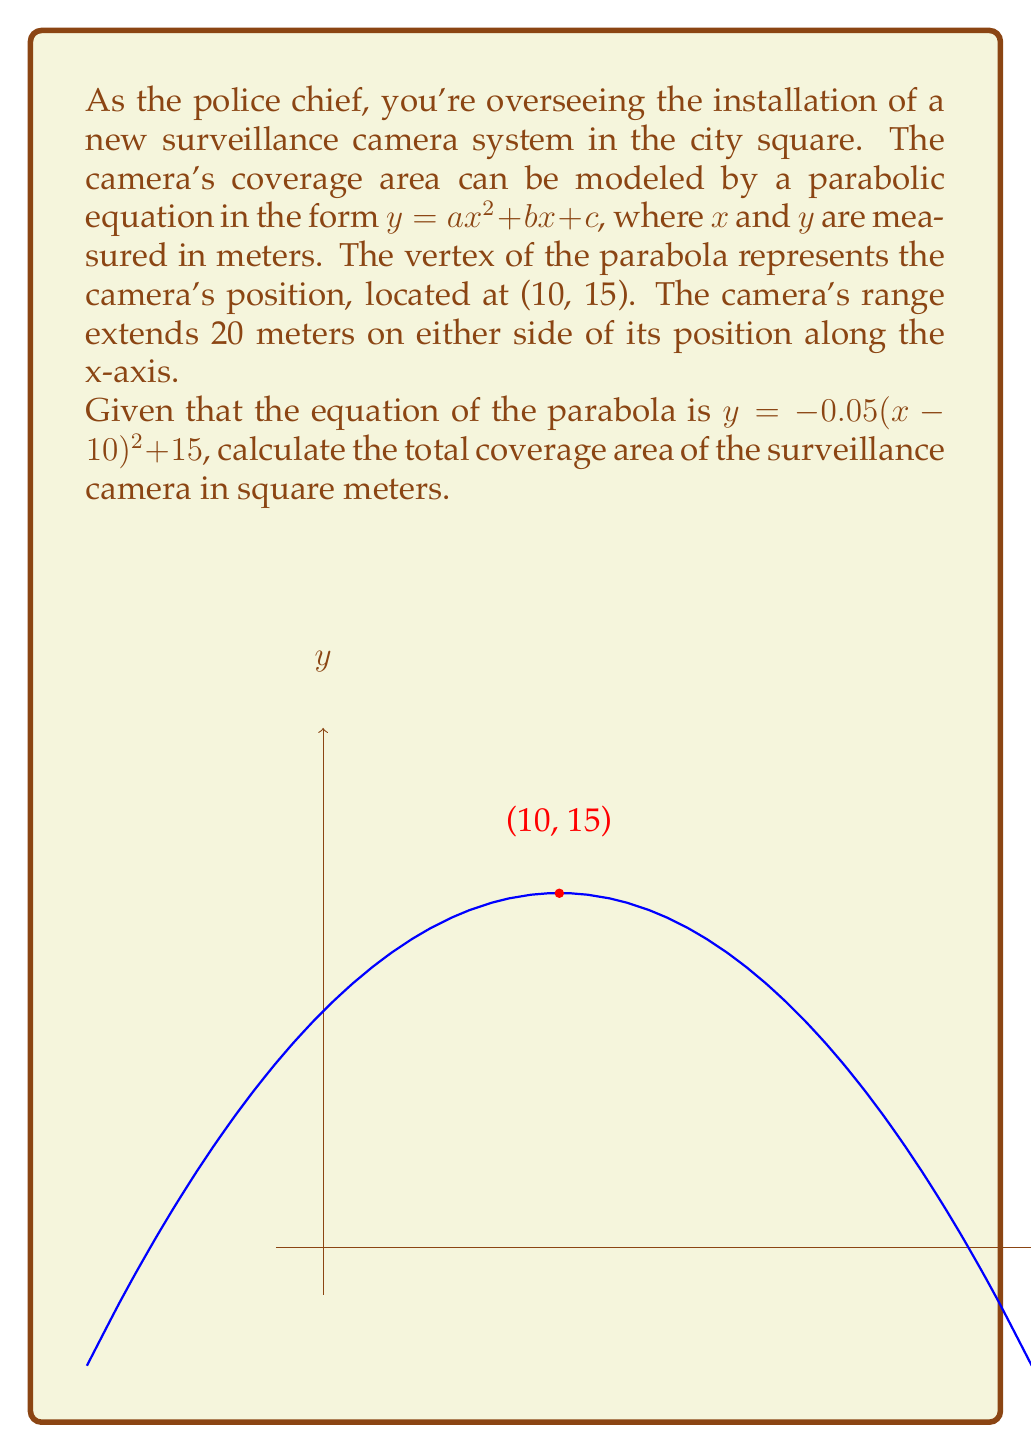What is the answer to this math problem? Let's approach this step-by-step:

1) The parabola equation is given as $y = -0.05(x-10)^2 + 15$

2) We need to find the area under this curve from $x = -10$ to $x = 30$ (20 meters on either side of the camera position at x = 10).

3) To calculate the area, we need to integrate the function:

   $$\text{Area} = \int_{-10}^{30} (-0.05(x-10)^2 + 15) dx$$

4) Let's solve this integral:
   
   $$\begin{align}
   \text{Area} &= \left[-0.05 \cdot \frac{(x-10)^3}{3} + 15x\right]_{-10}^{30} \\
   &= \left[-0.05 \cdot \frac{(30-10)^3}{3} + 15 \cdot 30\right] - \left[-0.05 \cdot \frac{(-10-10)^3}{3} + 15 \cdot (-10)\right] \\
   &= \left[-0.05 \cdot \frac{20^3}{3} + 450\right] - \left[-0.05 \cdot \frac{-20^3}{3} - 150\right] \\
   &= [-133.33 + 450] - [133.33 - 150] \\
   &= 316.67 + 16.67 \\
   &= 333.34
   \end{align}$$

5) Therefore, the total coverage area is approximately 333.34 square meters.
Answer: 333.34 m² 